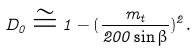Convert formula to latex. <formula><loc_0><loc_0><loc_500><loc_500>D _ { 0 } \cong 1 - ( \frac { m _ { t } } { 2 0 0 \sin { \beta } } ) ^ { 2 } .</formula> 